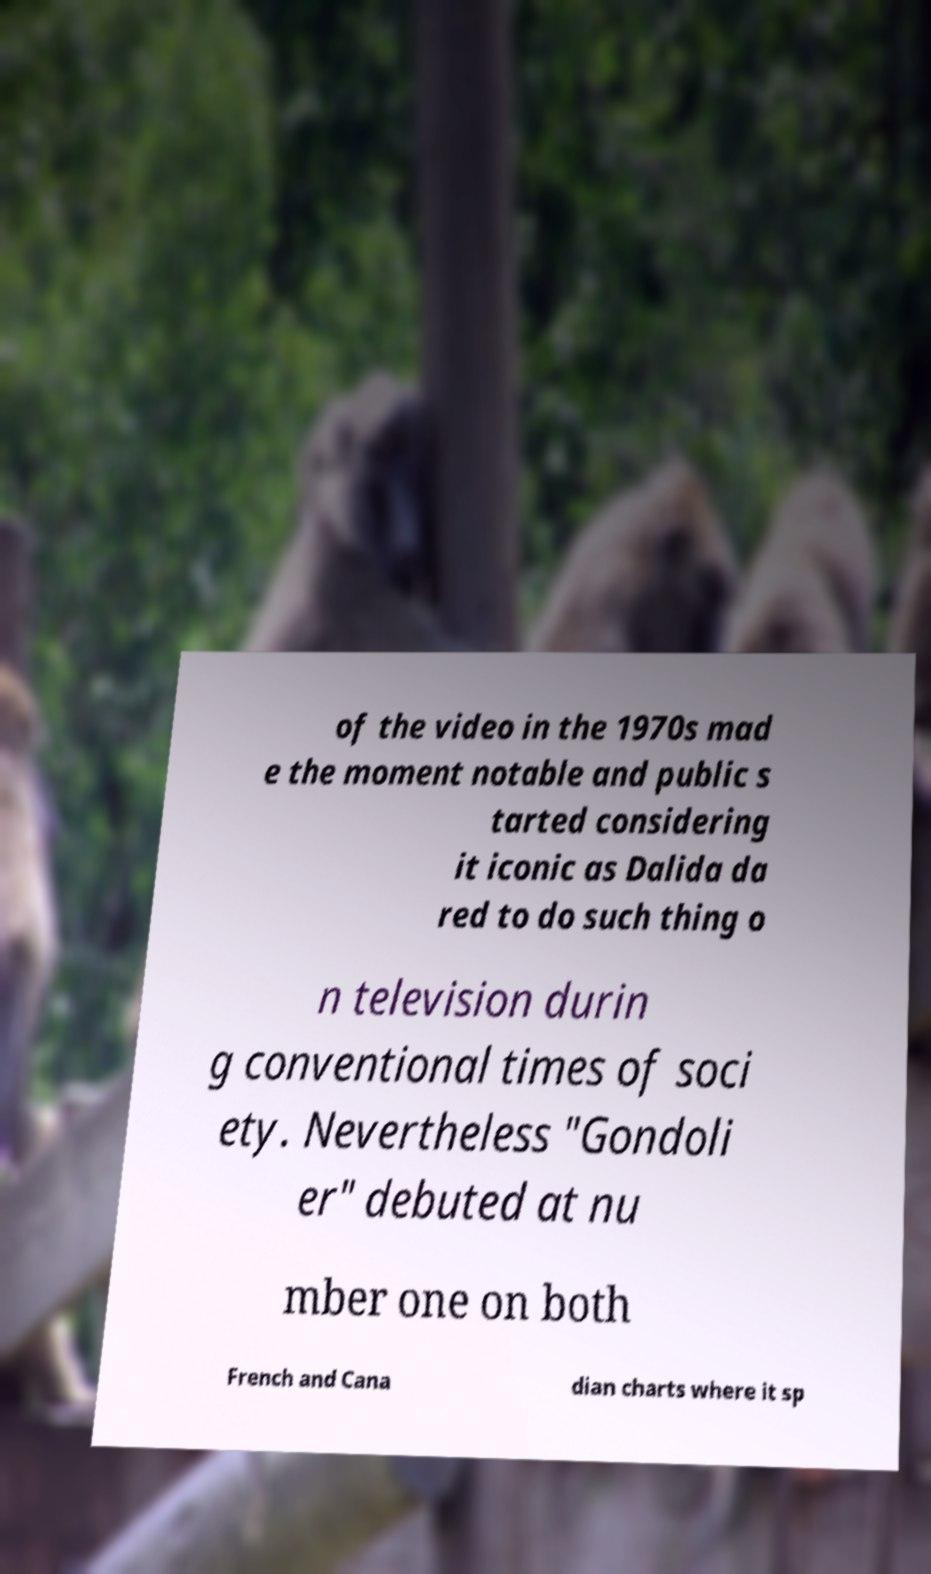Could you extract and type out the text from this image? of the video in the 1970s mad e the moment notable and public s tarted considering it iconic as Dalida da red to do such thing o n television durin g conventional times of soci ety. Nevertheless "Gondoli er" debuted at nu mber one on both French and Cana dian charts where it sp 